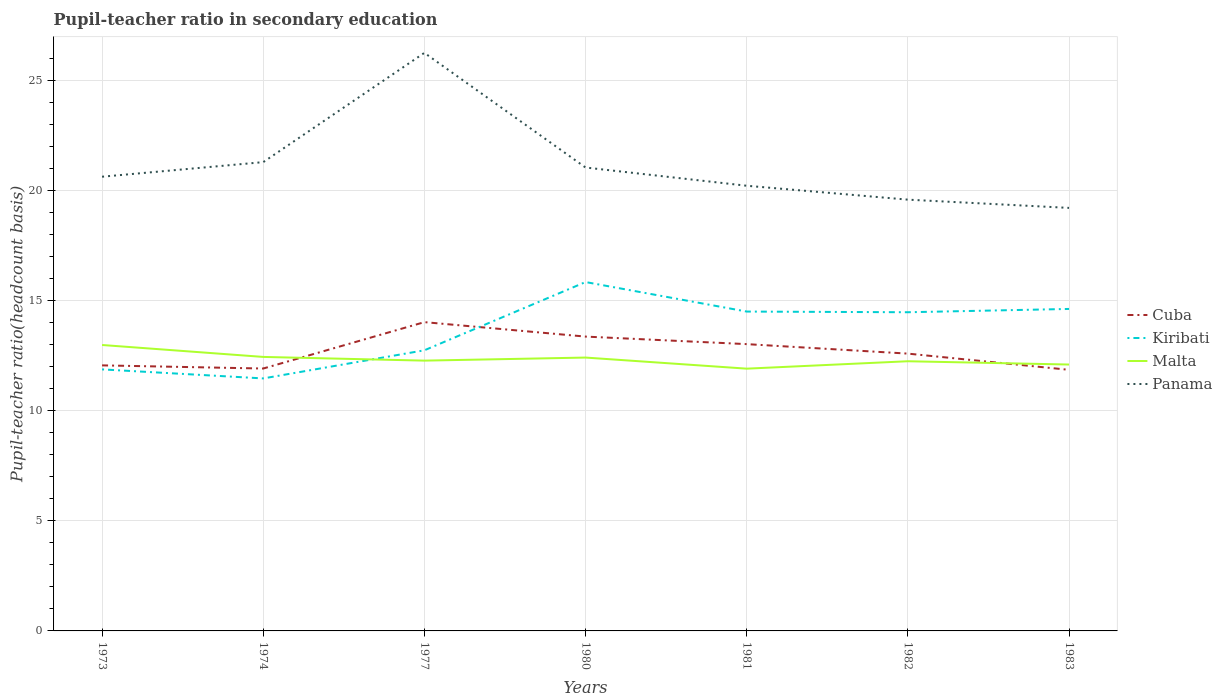How many different coloured lines are there?
Offer a very short reply. 4. Does the line corresponding to Kiribati intersect with the line corresponding to Cuba?
Ensure brevity in your answer.  Yes. Across all years, what is the maximum pupil-teacher ratio in secondary education in Panama?
Your answer should be compact. 19.21. What is the total pupil-teacher ratio in secondary education in Kiribati in the graph?
Your answer should be very brief. -4.38. What is the difference between the highest and the second highest pupil-teacher ratio in secondary education in Kiribati?
Provide a succinct answer. 4.38. How many lines are there?
Offer a very short reply. 4. How many years are there in the graph?
Keep it short and to the point. 7. Are the values on the major ticks of Y-axis written in scientific E-notation?
Provide a succinct answer. No. Does the graph contain any zero values?
Give a very brief answer. No. Does the graph contain grids?
Your response must be concise. Yes. How many legend labels are there?
Offer a very short reply. 4. How are the legend labels stacked?
Your answer should be very brief. Vertical. What is the title of the graph?
Your answer should be very brief. Pupil-teacher ratio in secondary education. What is the label or title of the Y-axis?
Provide a short and direct response. Pupil-teacher ratio(headcount basis). What is the Pupil-teacher ratio(headcount basis) in Cuba in 1973?
Your answer should be very brief. 12.06. What is the Pupil-teacher ratio(headcount basis) in Kiribati in 1973?
Your answer should be compact. 11.88. What is the Pupil-teacher ratio(headcount basis) of Malta in 1973?
Give a very brief answer. 12.99. What is the Pupil-teacher ratio(headcount basis) in Panama in 1973?
Provide a succinct answer. 20.63. What is the Pupil-teacher ratio(headcount basis) of Cuba in 1974?
Offer a very short reply. 11.92. What is the Pupil-teacher ratio(headcount basis) in Kiribati in 1974?
Offer a very short reply. 11.47. What is the Pupil-teacher ratio(headcount basis) in Malta in 1974?
Offer a very short reply. 12.44. What is the Pupil-teacher ratio(headcount basis) of Panama in 1974?
Your answer should be very brief. 21.29. What is the Pupil-teacher ratio(headcount basis) of Cuba in 1977?
Keep it short and to the point. 14.02. What is the Pupil-teacher ratio(headcount basis) of Kiribati in 1977?
Give a very brief answer. 12.75. What is the Pupil-teacher ratio(headcount basis) in Malta in 1977?
Your response must be concise. 12.28. What is the Pupil-teacher ratio(headcount basis) in Panama in 1977?
Offer a very short reply. 26.25. What is the Pupil-teacher ratio(headcount basis) in Cuba in 1980?
Your answer should be compact. 13.37. What is the Pupil-teacher ratio(headcount basis) in Kiribati in 1980?
Offer a very short reply. 15.84. What is the Pupil-teacher ratio(headcount basis) in Malta in 1980?
Give a very brief answer. 12.41. What is the Pupil-teacher ratio(headcount basis) in Panama in 1980?
Give a very brief answer. 21.05. What is the Pupil-teacher ratio(headcount basis) in Cuba in 1981?
Provide a short and direct response. 13.02. What is the Pupil-teacher ratio(headcount basis) of Kiribati in 1981?
Provide a short and direct response. 14.5. What is the Pupil-teacher ratio(headcount basis) in Malta in 1981?
Make the answer very short. 11.91. What is the Pupil-teacher ratio(headcount basis) of Panama in 1981?
Offer a very short reply. 20.22. What is the Pupil-teacher ratio(headcount basis) in Cuba in 1982?
Your answer should be very brief. 12.59. What is the Pupil-teacher ratio(headcount basis) of Kiribati in 1982?
Give a very brief answer. 14.47. What is the Pupil-teacher ratio(headcount basis) of Malta in 1982?
Keep it short and to the point. 12.25. What is the Pupil-teacher ratio(headcount basis) in Panama in 1982?
Make the answer very short. 19.59. What is the Pupil-teacher ratio(headcount basis) of Cuba in 1983?
Offer a very short reply. 11.86. What is the Pupil-teacher ratio(headcount basis) of Kiribati in 1983?
Ensure brevity in your answer.  14.62. What is the Pupil-teacher ratio(headcount basis) of Malta in 1983?
Make the answer very short. 12.1. What is the Pupil-teacher ratio(headcount basis) of Panama in 1983?
Provide a succinct answer. 19.21. Across all years, what is the maximum Pupil-teacher ratio(headcount basis) in Cuba?
Offer a very short reply. 14.02. Across all years, what is the maximum Pupil-teacher ratio(headcount basis) of Kiribati?
Offer a very short reply. 15.84. Across all years, what is the maximum Pupil-teacher ratio(headcount basis) of Malta?
Offer a terse response. 12.99. Across all years, what is the maximum Pupil-teacher ratio(headcount basis) in Panama?
Your answer should be compact. 26.25. Across all years, what is the minimum Pupil-teacher ratio(headcount basis) of Cuba?
Provide a short and direct response. 11.86. Across all years, what is the minimum Pupil-teacher ratio(headcount basis) of Kiribati?
Your answer should be compact. 11.47. Across all years, what is the minimum Pupil-teacher ratio(headcount basis) of Malta?
Ensure brevity in your answer.  11.91. Across all years, what is the minimum Pupil-teacher ratio(headcount basis) of Panama?
Make the answer very short. 19.21. What is the total Pupil-teacher ratio(headcount basis) of Cuba in the graph?
Ensure brevity in your answer.  88.85. What is the total Pupil-teacher ratio(headcount basis) of Kiribati in the graph?
Your response must be concise. 95.53. What is the total Pupil-teacher ratio(headcount basis) of Malta in the graph?
Ensure brevity in your answer.  86.38. What is the total Pupil-teacher ratio(headcount basis) in Panama in the graph?
Your answer should be very brief. 148.24. What is the difference between the Pupil-teacher ratio(headcount basis) in Cuba in 1973 and that in 1974?
Give a very brief answer. 0.14. What is the difference between the Pupil-teacher ratio(headcount basis) in Kiribati in 1973 and that in 1974?
Offer a very short reply. 0.41. What is the difference between the Pupil-teacher ratio(headcount basis) in Malta in 1973 and that in 1974?
Offer a very short reply. 0.54. What is the difference between the Pupil-teacher ratio(headcount basis) in Panama in 1973 and that in 1974?
Your response must be concise. -0.66. What is the difference between the Pupil-teacher ratio(headcount basis) in Cuba in 1973 and that in 1977?
Your response must be concise. -1.96. What is the difference between the Pupil-teacher ratio(headcount basis) of Kiribati in 1973 and that in 1977?
Make the answer very short. -0.87. What is the difference between the Pupil-teacher ratio(headcount basis) in Malta in 1973 and that in 1977?
Your answer should be compact. 0.71. What is the difference between the Pupil-teacher ratio(headcount basis) of Panama in 1973 and that in 1977?
Give a very brief answer. -5.63. What is the difference between the Pupil-teacher ratio(headcount basis) of Cuba in 1973 and that in 1980?
Make the answer very short. -1.31. What is the difference between the Pupil-teacher ratio(headcount basis) of Kiribati in 1973 and that in 1980?
Ensure brevity in your answer.  -3.97. What is the difference between the Pupil-teacher ratio(headcount basis) in Malta in 1973 and that in 1980?
Ensure brevity in your answer.  0.57. What is the difference between the Pupil-teacher ratio(headcount basis) in Panama in 1973 and that in 1980?
Provide a succinct answer. -0.42. What is the difference between the Pupil-teacher ratio(headcount basis) of Cuba in 1973 and that in 1981?
Offer a terse response. -0.96. What is the difference between the Pupil-teacher ratio(headcount basis) of Kiribati in 1973 and that in 1981?
Give a very brief answer. -2.63. What is the difference between the Pupil-teacher ratio(headcount basis) in Malta in 1973 and that in 1981?
Your response must be concise. 1.07. What is the difference between the Pupil-teacher ratio(headcount basis) in Panama in 1973 and that in 1981?
Ensure brevity in your answer.  0.41. What is the difference between the Pupil-teacher ratio(headcount basis) in Cuba in 1973 and that in 1982?
Ensure brevity in your answer.  -0.53. What is the difference between the Pupil-teacher ratio(headcount basis) of Kiribati in 1973 and that in 1982?
Your response must be concise. -2.6. What is the difference between the Pupil-teacher ratio(headcount basis) of Malta in 1973 and that in 1982?
Provide a succinct answer. 0.74. What is the difference between the Pupil-teacher ratio(headcount basis) in Panama in 1973 and that in 1982?
Offer a terse response. 1.04. What is the difference between the Pupil-teacher ratio(headcount basis) in Cuba in 1973 and that in 1983?
Your answer should be compact. 0.2. What is the difference between the Pupil-teacher ratio(headcount basis) in Kiribati in 1973 and that in 1983?
Give a very brief answer. -2.75. What is the difference between the Pupil-teacher ratio(headcount basis) in Malta in 1973 and that in 1983?
Keep it short and to the point. 0.89. What is the difference between the Pupil-teacher ratio(headcount basis) of Panama in 1973 and that in 1983?
Make the answer very short. 1.42. What is the difference between the Pupil-teacher ratio(headcount basis) in Cuba in 1974 and that in 1977?
Keep it short and to the point. -2.11. What is the difference between the Pupil-teacher ratio(headcount basis) of Kiribati in 1974 and that in 1977?
Your answer should be very brief. -1.28. What is the difference between the Pupil-teacher ratio(headcount basis) of Malta in 1974 and that in 1977?
Ensure brevity in your answer.  0.17. What is the difference between the Pupil-teacher ratio(headcount basis) in Panama in 1974 and that in 1977?
Make the answer very short. -4.96. What is the difference between the Pupil-teacher ratio(headcount basis) of Cuba in 1974 and that in 1980?
Your response must be concise. -1.45. What is the difference between the Pupil-teacher ratio(headcount basis) in Kiribati in 1974 and that in 1980?
Offer a very short reply. -4.38. What is the difference between the Pupil-teacher ratio(headcount basis) in Malta in 1974 and that in 1980?
Offer a very short reply. 0.03. What is the difference between the Pupil-teacher ratio(headcount basis) in Panama in 1974 and that in 1980?
Offer a terse response. 0.24. What is the difference between the Pupil-teacher ratio(headcount basis) of Cuba in 1974 and that in 1981?
Offer a very short reply. -1.11. What is the difference between the Pupil-teacher ratio(headcount basis) of Kiribati in 1974 and that in 1981?
Give a very brief answer. -3.04. What is the difference between the Pupil-teacher ratio(headcount basis) of Malta in 1974 and that in 1981?
Give a very brief answer. 0.53. What is the difference between the Pupil-teacher ratio(headcount basis) in Panama in 1974 and that in 1981?
Make the answer very short. 1.07. What is the difference between the Pupil-teacher ratio(headcount basis) in Cuba in 1974 and that in 1982?
Offer a very short reply. -0.68. What is the difference between the Pupil-teacher ratio(headcount basis) in Kiribati in 1974 and that in 1982?
Your answer should be very brief. -3.01. What is the difference between the Pupil-teacher ratio(headcount basis) in Malta in 1974 and that in 1982?
Keep it short and to the point. 0.2. What is the difference between the Pupil-teacher ratio(headcount basis) in Panama in 1974 and that in 1982?
Offer a terse response. 1.7. What is the difference between the Pupil-teacher ratio(headcount basis) of Cuba in 1974 and that in 1983?
Offer a terse response. 0.06. What is the difference between the Pupil-teacher ratio(headcount basis) of Kiribati in 1974 and that in 1983?
Give a very brief answer. -3.16. What is the difference between the Pupil-teacher ratio(headcount basis) of Malta in 1974 and that in 1983?
Offer a very short reply. 0.35. What is the difference between the Pupil-teacher ratio(headcount basis) of Panama in 1974 and that in 1983?
Keep it short and to the point. 2.08. What is the difference between the Pupil-teacher ratio(headcount basis) of Cuba in 1977 and that in 1980?
Keep it short and to the point. 0.66. What is the difference between the Pupil-teacher ratio(headcount basis) in Kiribati in 1977 and that in 1980?
Offer a very short reply. -3.1. What is the difference between the Pupil-teacher ratio(headcount basis) in Malta in 1977 and that in 1980?
Your answer should be very brief. -0.14. What is the difference between the Pupil-teacher ratio(headcount basis) in Panama in 1977 and that in 1980?
Keep it short and to the point. 5.21. What is the difference between the Pupil-teacher ratio(headcount basis) of Kiribati in 1977 and that in 1981?
Keep it short and to the point. -1.76. What is the difference between the Pupil-teacher ratio(headcount basis) in Malta in 1977 and that in 1981?
Keep it short and to the point. 0.37. What is the difference between the Pupil-teacher ratio(headcount basis) in Panama in 1977 and that in 1981?
Your answer should be compact. 6.04. What is the difference between the Pupil-teacher ratio(headcount basis) in Cuba in 1977 and that in 1982?
Your response must be concise. 1.43. What is the difference between the Pupil-teacher ratio(headcount basis) in Kiribati in 1977 and that in 1982?
Offer a very short reply. -1.73. What is the difference between the Pupil-teacher ratio(headcount basis) of Malta in 1977 and that in 1982?
Your response must be concise. 0.03. What is the difference between the Pupil-teacher ratio(headcount basis) in Panama in 1977 and that in 1982?
Your response must be concise. 6.67. What is the difference between the Pupil-teacher ratio(headcount basis) in Cuba in 1977 and that in 1983?
Make the answer very short. 2.17. What is the difference between the Pupil-teacher ratio(headcount basis) in Kiribati in 1977 and that in 1983?
Give a very brief answer. -1.88. What is the difference between the Pupil-teacher ratio(headcount basis) in Malta in 1977 and that in 1983?
Make the answer very short. 0.18. What is the difference between the Pupil-teacher ratio(headcount basis) in Panama in 1977 and that in 1983?
Your response must be concise. 7.04. What is the difference between the Pupil-teacher ratio(headcount basis) in Cuba in 1980 and that in 1981?
Provide a succinct answer. 0.34. What is the difference between the Pupil-teacher ratio(headcount basis) in Kiribati in 1980 and that in 1981?
Provide a short and direct response. 1.34. What is the difference between the Pupil-teacher ratio(headcount basis) in Malta in 1980 and that in 1981?
Make the answer very short. 0.5. What is the difference between the Pupil-teacher ratio(headcount basis) in Panama in 1980 and that in 1981?
Ensure brevity in your answer.  0.83. What is the difference between the Pupil-teacher ratio(headcount basis) in Cuba in 1980 and that in 1982?
Provide a short and direct response. 0.77. What is the difference between the Pupil-teacher ratio(headcount basis) of Kiribati in 1980 and that in 1982?
Give a very brief answer. 1.37. What is the difference between the Pupil-teacher ratio(headcount basis) of Malta in 1980 and that in 1982?
Your answer should be very brief. 0.17. What is the difference between the Pupil-teacher ratio(headcount basis) of Panama in 1980 and that in 1982?
Provide a succinct answer. 1.46. What is the difference between the Pupil-teacher ratio(headcount basis) in Cuba in 1980 and that in 1983?
Your response must be concise. 1.51. What is the difference between the Pupil-teacher ratio(headcount basis) in Kiribati in 1980 and that in 1983?
Keep it short and to the point. 1.22. What is the difference between the Pupil-teacher ratio(headcount basis) of Malta in 1980 and that in 1983?
Provide a short and direct response. 0.32. What is the difference between the Pupil-teacher ratio(headcount basis) of Panama in 1980 and that in 1983?
Provide a succinct answer. 1.83. What is the difference between the Pupil-teacher ratio(headcount basis) of Cuba in 1981 and that in 1982?
Your answer should be very brief. 0.43. What is the difference between the Pupil-teacher ratio(headcount basis) in Kiribati in 1981 and that in 1982?
Your response must be concise. 0.03. What is the difference between the Pupil-teacher ratio(headcount basis) of Malta in 1981 and that in 1982?
Your answer should be very brief. -0.34. What is the difference between the Pupil-teacher ratio(headcount basis) of Panama in 1981 and that in 1982?
Give a very brief answer. 0.63. What is the difference between the Pupil-teacher ratio(headcount basis) in Cuba in 1981 and that in 1983?
Provide a succinct answer. 1.17. What is the difference between the Pupil-teacher ratio(headcount basis) of Kiribati in 1981 and that in 1983?
Your response must be concise. -0.12. What is the difference between the Pupil-teacher ratio(headcount basis) in Malta in 1981 and that in 1983?
Your response must be concise. -0.19. What is the difference between the Pupil-teacher ratio(headcount basis) in Panama in 1981 and that in 1983?
Provide a short and direct response. 1.01. What is the difference between the Pupil-teacher ratio(headcount basis) of Cuba in 1982 and that in 1983?
Make the answer very short. 0.74. What is the difference between the Pupil-teacher ratio(headcount basis) of Kiribati in 1982 and that in 1983?
Offer a terse response. -0.15. What is the difference between the Pupil-teacher ratio(headcount basis) of Malta in 1982 and that in 1983?
Keep it short and to the point. 0.15. What is the difference between the Pupil-teacher ratio(headcount basis) in Panama in 1982 and that in 1983?
Your answer should be compact. 0.37. What is the difference between the Pupil-teacher ratio(headcount basis) of Cuba in 1973 and the Pupil-teacher ratio(headcount basis) of Kiribati in 1974?
Your response must be concise. 0.59. What is the difference between the Pupil-teacher ratio(headcount basis) of Cuba in 1973 and the Pupil-teacher ratio(headcount basis) of Malta in 1974?
Provide a short and direct response. -0.38. What is the difference between the Pupil-teacher ratio(headcount basis) in Cuba in 1973 and the Pupil-teacher ratio(headcount basis) in Panama in 1974?
Your answer should be compact. -9.23. What is the difference between the Pupil-teacher ratio(headcount basis) of Kiribati in 1973 and the Pupil-teacher ratio(headcount basis) of Malta in 1974?
Your response must be concise. -0.57. What is the difference between the Pupil-teacher ratio(headcount basis) of Kiribati in 1973 and the Pupil-teacher ratio(headcount basis) of Panama in 1974?
Your answer should be compact. -9.41. What is the difference between the Pupil-teacher ratio(headcount basis) of Malta in 1973 and the Pupil-teacher ratio(headcount basis) of Panama in 1974?
Your answer should be compact. -8.3. What is the difference between the Pupil-teacher ratio(headcount basis) of Cuba in 1973 and the Pupil-teacher ratio(headcount basis) of Kiribati in 1977?
Keep it short and to the point. -0.68. What is the difference between the Pupil-teacher ratio(headcount basis) of Cuba in 1973 and the Pupil-teacher ratio(headcount basis) of Malta in 1977?
Offer a terse response. -0.22. What is the difference between the Pupil-teacher ratio(headcount basis) in Cuba in 1973 and the Pupil-teacher ratio(headcount basis) in Panama in 1977?
Offer a terse response. -14.19. What is the difference between the Pupil-teacher ratio(headcount basis) of Kiribati in 1973 and the Pupil-teacher ratio(headcount basis) of Malta in 1977?
Give a very brief answer. -0.4. What is the difference between the Pupil-teacher ratio(headcount basis) in Kiribati in 1973 and the Pupil-teacher ratio(headcount basis) in Panama in 1977?
Give a very brief answer. -14.38. What is the difference between the Pupil-teacher ratio(headcount basis) of Malta in 1973 and the Pupil-teacher ratio(headcount basis) of Panama in 1977?
Your answer should be very brief. -13.27. What is the difference between the Pupil-teacher ratio(headcount basis) in Cuba in 1973 and the Pupil-teacher ratio(headcount basis) in Kiribati in 1980?
Your answer should be compact. -3.78. What is the difference between the Pupil-teacher ratio(headcount basis) in Cuba in 1973 and the Pupil-teacher ratio(headcount basis) in Malta in 1980?
Your response must be concise. -0.35. What is the difference between the Pupil-teacher ratio(headcount basis) of Cuba in 1973 and the Pupil-teacher ratio(headcount basis) of Panama in 1980?
Offer a very short reply. -8.99. What is the difference between the Pupil-teacher ratio(headcount basis) of Kiribati in 1973 and the Pupil-teacher ratio(headcount basis) of Malta in 1980?
Your answer should be compact. -0.54. What is the difference between the Pupil-teacher ratio(headcount basis) in Kiribati in 1973 and the Pupil-teacher ratio(headcount basis) in Panama in 1980?
Ensure brevity in your answer.  -9.17. What is the difference between the Pupil-teacher ratio(headcount basis) in Malta in 1973 and the Pupil-teacher ratio(headcount basis) in Panama in 1980?
Make the answer very short. -8.06. What is the difference between the Pupil-teacher ratio(headcount basis) in Cuba in 1973 and the Pupil-teacher ratio(headcount basis) in Kiribati in 1981?
Offer a very short reply. -2.44. What is the difference between the Pupil-teacher ratio(headcount basis) in Cuba in 1973 and the Pupil-teacher ratio(headcount basis) in Malta in 1981?
Your answer should be very brief. 0.15. What is the difference between the Pupil-teacher ratio(headcount basis) in Cuba in 1973 and the Pupil-teacher ratio(headcount basis) in Panama in 1981?
Provide a succinct answer. -8.16. What is the difference between the Pupil-teacher ratio(headcount basis) in Kiribati in 1973 and the Pupil-teacher ratio(headcount basis) in Malta in 1981?
Ensure brevity in your answer.  -0.03. What is the difference between the Pupil-teacher ratio(headcount basis) in Kiribati in 1973 and the Pupil-teacher ratio(headcount basis) in Panama in 1981?
Your answer should be very brief. -8.34. What is the difference between the Pupil-teacher ratio(headcount basis) in Malta in 1973 and the Pupil-teacher ratio(headcount basis) in Panama in 1981?
Your answer should be very brief. -7.23. What is the difference between the Pupil-teacher ratio(headcount basis) in Cuba in 1973 and the Pupil-teacher ratio(headcount basis) in Kiribati in 1982?
Keep it short and to the point. -2.41. What is the difference between the Pupil-teacher ratio(headcount basis) in Cuba in 1973 and the Pupil-teacher ratio(headcount basis) in Malta in 1982?
Keep it short and to the point. -0.19. What is the difference between the Pupil-teacher ratio(headcount basis) in Cuba in 1973 and the Pupil-teacher ratio(headcount basis) in Panama in 1982?
Provide a succinct answer. -7.53. What is the difference between the Pupil-teacher ratio(headcount basis) in Kiribati in 1973 and the Pupil-teacher ratio(headcount basis) in Malta in 1982?
Provide a succinct answer. -0.37. What is the difference between the Pupil-teacher ratio(headcount basis) in Kiribati in 1973 and the Pupil-teacher ratio(headcount basis) in Panama in 1982?
Offer a very short reply. -7.71. What is the difference between the Pupil-teacher ratio(headcount basis) of Malta in 1973 and the Pupil-teacher ratio(headcount basis) of Panama in 1982?
Provide a short and direct response. -6.6. What is the difference between the Pupil-teacher ratio(headcount basis) in Cuba in 1973 and the Pupil-teacher ratio(headcount basis) in Kiribati in 1983?
Keep it short and to the point. -2.56. What is the difference between the Pupil-teacher ratio(headcount basis) in Cuba in 1973 and the Pupil-teacher ratio(headcount basis) in Malta in 1983?
Your answer should be very brief. -0.04. What is the difference between the Pupil-teacher ratio(headcount basis) in Cuba in 1973 and the Pupil-teacher ratio(headcount basis) in Panama in 1983?
Offer a terse response. -7.15. What is the difference between the Pupil-teacher ratio(headcount basis) of Kiribati in 1973 and the Pupil-teacher ratio(headcount basis) of Malta in 1983?
Provide a succinct answer. -0.22. What is the difference between the Pupil-teacher ratio(headcount basis) in Kiribati in 1973 and the Pupil-teacher ratio(headcount basis) in Panama in 1983?
Ensure brevity in your answer.  -7.33. What is the difference between the Pupil-teacher ratio(headcount basis) in Malta in 1973 and the Pupil-teacher ratio(headcount basis) in Panama in 1983?
Make the answer very short. -6.23. What is the difference between the Pupil-teacher ratio(headcount basis) of Cuba in 1974 and the Pupil-teacher ratio(headcount basis) of Kiribati in 1977?
Keep it short and to the point. -0.83. What is the difference between the Pupil-teacher ratio(headcount basis) of Cuba in 1974 and the Pupil-teacher ratio(headcount basis) of Malta in 1977?
Offer a terse response. -0.36. What is the difference between the Pupil-teacher ratio(headcount basis) of Cuba in 1974 and the Pupil-teacher ratio(headcount basis) of Panama in 1977?
Your answer should be compact. -14.34. What is the difference between the Pupil-teacher ratio(headcount basis) of Kiribati in 1974 and the Pupil-teacher ratio(headcount basis) of Malta in 1977?
Provide a succinct answer. -0.81. What is the difference between the Pupil-teacher ratio(headcount basis) in Kiribati in 1974 and the Pupil-teacher ratio(headcount basis) in Panama in 1977?
Make the answer very short. -14.79. What is the difference between the Pupil-teacher ratio(headcount basis) in Malta in 1974 and the Pupil-teacher ratio(headcount basis) in Panama in 1977?
Keep it short and to the point. -13.81. What is the difference between the Pupil-teacher ratio(headcount basis) of Cuba in 1974 and the Pupil-teacher ratio(headcount basis) of Kiribati in 1980?
Give a very brief answer. -3.93. What is the difference between the Pupil-teacher ratio(headcount basis) of Cuba in 1974 and the Pupil-teacher ratio(headcount basis) of Malta in 1980?
Offer a very short reply. -0.5. What is the difference between the Pupil-teacher ratio(headcount basis) of Cuba in 1974 and the Pupil-teacher ratio(headcount basis) of Panama in 1980?
Your answer should be very brief. -9.13. What is the difference between the Pupil-teacher ratio(headcount basis) of Kiribati in 1974 and the Pupil-teacher ratio(headcount basis) of Malta in 1980?
Make the answer very short. -0.95. What is the difference between the Pupil-teacher ratio(headcount basis) of Kiribati in 1974 and the Pupil-teacher ratio(headcount basis) of Panama in 1980?
Your response must be concise. -9.58. What is the difference between the Pupil-teacher ratio(headcount basis) in Malta in 1974 and the Pupil-teacher ratio(headcount basis) in Panama in 1980?
Give a very brief answer. -8.6. What is the difference between the Pupil-teacher ratio(headcount basis) of Cuba in 1974 and the Pupil-teacher ratio(headcount basis) of Kiribati in 1981?
Offer a very short reply. -2.59. What is the difference between the Pupil-teacher ratio(headcount basis) of Cuba in 1974 and the Pupil-teacher ratio(headcount basis) of Malta in 1981?
Give a very brief answer. 0.01. What is the difference between the Pupil-teacher ratio(headcount basis) of Cuba in 1974 and the Pupil-teacher ratio(headcount basis) of Panama in 1981?
Offer a very short reply. -8.3. What is the difference between the Pupil-teacher ratio(headcount basis) in Kiribati in 1974 and the Pupil-teacher ratio(headcount basis) in Malta in 1981?
Provide a succinct answer. -0.44. What is the difference between the Pupil-teacher ratio(headcount basis) in Kiribati in 1974 and the Pupil-teacher ratio(headcount basis) in Panama in 1981?
Provide a short and direct response. -8.75. What is the difference between the Pupil-teacher ratio(headcount basis) of Malta in 1974 and the Pupil-teacher ratio(headcount basis) of Panama in 1981?
Provide a short and direct response. -7.77. What is the difference between the Pupil-teacher ratio(headcount basis) in Cuba in 1974 and the Pupil-teacher ratio(headcount basis) in Kiribati in 1982?
Your answer should be compact. -2.56. What is the difference between the Pupil-teacher ratio(headcount basis) in Cuba in 1974 and the Pupil-teacher ratio(headcount basis) in Malta in 1982?
Offer a terse response. -0.33. What is the difference between the Pupil-teacher ratio(headcount basis) of Cuba in 1974 and the Pupil-teacher ratio(headcount basis) of Panama in 1982?
Your answer should be compact. -7.67. What is the difference between the Pupil-teacher ratio(headcount basis) in Kiribati in 1974 and the Pupil-teacher ratio(headcount basis) in Malta in 1982?
Ensure brevity in your answer.  -0.78. What is the difference between the Pupil-teacher ratio(headcount basis) in Kiribati in 1974 and the Pupil-teacher ratio(headcount basis) in Panama in 1982?
Your answer should be compact. -8.12. What is the difference between the Pupil-teacher ratio(headcount basis) of Malta in 1974 and the Pupil-teacher ratio(headcount basis) of Panama in 1982?
Ensure brevity in your answer.  -7.14. What is the difference between the Pupil-teacher ratio(headcount basis) of Cuba in 1974 and the Pupil-teacher ratio(headcount basis) of Kiribati in 1983?
Provide a succinct answer. -2.71. What is the difference between the Pupil-teacher ratio(headcount basis) in Cuba in 1974 and the Pupil-teacher ratio(headcount basis) in Malta in 1983?
Provide a succinct answer. -0.18. What is the difference between the Pupil-teacher ratio(headcount basis) of Cuba in 1974 and the Pupil-teacher ratio(headcount basis) of Panama in 1983?
Provide a short and direct response. -7.29. What is the difference between the Pupil-teacher ratio(headcount basis) of Kiribati in 1974 and the Pupil-teacher ratio(headcount basis) of Malta in 1983?
Keep it short and to the point. -0.63. What is the difference between the Pupil-teacher ratio(headcount basis) in Kiribati in 1974 and the Pupil-teacher ratio(headcount basis) in Panama in 1983?
Offer a terse response. -7.74. What is the difference between the Pupil-teacher ratio(headcount basis) of Malta in 1974 and the Pupil-teacher ratio(headcount basis) of Panama in 1983?
Make the answer very short. -6.77. What is the difference between the Pupil-teacher ratio(headcount basis) of Cuba in 1977 and the Pupil-teacher ratio(headcount basis) of Kiribati in 1980?
Keep it short and to the point. -1.82. What is the difference between the Pupil-teacher ratio(headcount basis) of Cuba in 1977 and the Pupil-teacher ratio(headcount basis) of Malta in 1980?
Your response must be concise. 1.61. What is the difference between the Pupil-teacher ratio(headcount basis) in Cuba in 1977 and the Pupil-teacher ratio(headcount basis) in Panama in 1980?
Your answer should be very brief. -7.02. What is the difference between the Pupil-teacher ratio(headcount basis) of Kiribati in 1977 and the Pupil-teacher ratio(headcount basis) of Malta in 1980?
Ensure brevity in your answer.  0.33. What is the difference between the Pupil-teacher ratio(headcount basis) in Kiribati in 1977 and the Pupil-teacher ratio(headcount basis) in Panama in 1980?
Ensure brevity in your answer.  -8.3. What is the difference between the Pupil-teacher ratio(headcount basis) of Malta in 1977 and the Pupil-teacher ratio(headcount basis) of Panama in 1980?
Your answer should be very brief. -8.77. What is the difference between the Pupil-teacher ratio(headcount basis) in Cuba in 1977 and the Pupil-teacher ratio(headcount basis) in Kiribati in 1981?
Give a very brief answer. -0.48. What is the difference between the Pupil-teacher ratio(headcount basis) of Cuba in 1977 and the Pupil-teacher ratio(headcount basis) of Malta in 1981?
Your answer should be compact. 2.11. What is the difference between the Pupil-teacher ratio(headcount basis) of Cuba in 1977 and the Pupil-teacher ratio(headcount basis) of Panama in 1981?
Give a very brief answer. -6.19. What is the difference between the Pupil-teacher ratio(headcount basis) in Kiribati in 1977 and the Pupil-teacher ratio(headcount basis) in Malta in 1981?
Your response must be concise. 0.83. What is the difference between the Pupil-teacher ratio(headcount basis) in Kiribati in 1977 and the Pupil-teacher ratio(headcount basis) in Panama in 1981?
Ensure brevity in your answer.  -7.47. What is the difference between the Pupil-teacher ratio(headcount basis) of Malta in 1977 and the Pupil-teacher ratio(headcount basis) of Panama in 1981?
Ensure brevity in your answer.  -7.94. What is the difference between the Pupil-teacher ratio(headcount basis) of Cuba in 1977 and the Pupil-teacher ratio(headcount basis) of Kiribati in 1982?
Ensure brevity in your answer.  -0.45. What is the difference between the Pupil-teacher ratio(headcount basis) of Cuba in 1977 and the Pupil-teacher ratio(headcount basis) of Malta in 1982?
Ensure brevity in your answer.  1.78. What is the difference between the Pupil-teacher ratio(headcount basis) of Cuba in 1977 and the Pupil-teacher ratio(headcount basis) of Panama in 1982?
Make the answer very short. -5.56. What is the difference between the Pupil-teacher ratio(headcount basis) in Kiribati in 1977 and the Pupil-teacher ratio(headcount basis) in Malta in 1982?
Offer a terse response. 0.5. What is the difference between the Pupil-teacher ratio(headcount basis) in Kiribati in 1977 and the Pupil-teacher ratio(headcount basis) in Panama in 1982?
Offer a very short reply. -6.84. What is the difference between the Pupil-teacher ratio(headcount basis) in Malta in 1977 and the Pupil-teacher ratio(headcount basis) in Panama in 1982?
Make the answer very short. -7.31. What is the difference between the Pupil-teacher ratio(headcount basis) of Cuba in 1977 and the Pupil-teacher ratio(headcount basis) of Kiribati in 1983?
Give a very brief answer. -0.6. What is the difference between the Pupil-teacher ratio(headcount basis) of Cuba in 1977 and the Pupil-teacher ratio(headcount basis) of Malta in 1983?
Provide a short and direct response. 1.93. What is the difference between the Pupil-teacher ratio(headcount basis) in Cuba in 1977 and the Pupil-teacher ratio(headcount basis) in Panama in 1983?
Keep it short and to the point. -5.19. What is the difference between the Pupil-teacher ratio(headcount basis) of Kiribati in 1977 and the Pupil-teacher ratio(headcount basis) of Malta in 1983?
Provide a short and direct response. 0.65. What is the difference between the Pupil-teacher ratio(headcount basis) in Kiribati in 1977 and the Pupil-teacher ratio(headcount basis) in Panama in 1983?
Your answer should be compact. -6.47. What is the difference between the Pupil-teacher ratio(headcount basis) of Malta in 1977 and the Pupil-teacher ratio(headcount basis) of Panama in 1983?
Make the answer very short. -6.94. What is the difference between the Pupil-teacher ratio(headcount basis) of Cuba in 1980 and the Pupil-teacher ratio(headcount basis) of Kiribati in 1981?
Offer a terse response. -1.14. What is the difference between the Pupil-teacher ratio(headcount basis) in Cuba in 1980 and the Pupil-teacher ratio(headcount basis) in Malta in 1981?
Your response must be concise. 1.46. What is the difference between the Pupil-teacher ratio(headcount basis) of Cuba in 1980 and the Pupil-teacher ratio(headcount basis) of Panama in 1981?
Provide a succinct answer. -6.85. What is the difference between the Pupil-teacher ratio(headcount basis) in Kiribati in 1980 and the Pupil-teacher ratio(headcount basis) in Malta in 1981?
Your response must be concise. 3.93. What is the difference between the Pupil-teacher ratio(headcount basis) of Kiribati in 1980 and the Pupil-teacher ratio(headcount basis) of Panama in 1981?
Keep it short and to the point. -4.37. What is the difference between the Pupil-teacher ratio(headcount basis) in Malta in 1980 and the Pupil-teacher ratio(headcount basis) in Panama in 1981?
Make the answer very short. -7.8. What is the difference between the Pupil-teacher ratio(headcount basis) in Cuba in 1980 and the Pupil-teacher ratio(headcount basis) in Kiribati in 1982?
Keep it short and to the point. -1.11. What is the difference between the Pupil-teacher ratio(headcount basis) of Cuba in 1980 and the Pupil-teacher ratio(headcount basis) of Malta in 1982?
Offer a very short reply. 1.12. What is the difference between the Pupil-teacher ratio(headcount basis) in Cuba in 1980 and the Pupil-teacher ratio(headcount basis) in Panama in 1982?
Offer a terse response. -6.22. What is the difference between the Pupil-teacher ratio(headcount basis) of Kiribati in 1980 and the Pupil-teacher ratio(headcount basis) of Malta in 1982?
Ensure brevity in your answer.  3.6. What is the difference between the Pupil-teacher ratio(headcount basis) in Kiribati in 1980 and the Pupil-teacher ratio(headcount basis) in Panama in 1982?
Your response must be concise. -3.74. What is the difference between the Pupil-teacher ratio(headcount basis) in Malta in 1980 and the Pupil-teacher ratio(headcount basis) in Panama in 1982?
Your response must be concise. -7.17. What is the difference between the Pupil-teacher ratio(headcount basis) in Cuba in 1980 and the Pupil-teacher ratio(headcount basis) in Kiribati in 1983?
Provide a succinct answer. -1.26. What is the difference between the Pupil-teacher ratio(headcount basis) in Cuba in 1980 and the Pupil-teacher ratio(headcount basis) in Malta in 1983?
Keep it short and to the point. 1.27. What is the difference between the Pupil-teacher ratio(headcount basis) of Cuba in 1980 and the Pupil-teacher ratio(headcount basis) of Panama in 1983?
Your response must be concise. -5.84. What is the difference between the Pupil-teacher ratio(headcount basis) of Kiribati in 1980 and the Pupil-teacher ratio(headcount basis) of Malta in 1983?
Offer a terse response. 3.75. What is the difference between the Pupil-teacher ratio(headcount basis) of Kiribati in 1980 and the Pupil-teacher ratio(headcount basis) of Panama in 1983?
Your answer should be very brief. -3.37. What is the difference between the Pupil-teacher ratio(headcount basis) of Malta in 1980 and the Pupil-teacher ratio(headcount basis) of Panama in 1983?
Offer a very short reply. -6.8. What is the difference between the Pupil-teacher ratio(headcount basis) in Cuba in 1981 and the Pupil-teacher ratio(headcount basis) in Kiribati in 1982?
Provide a succinct answer. -1.45. What is the difference between the Pupil-teacher ratio(headcount basis) of Cuba in 1981 and the Pupil-teacher ratio(headcount basis) of Malta in 1982?
Your response must be concise. 0.78. What is the difference between the Pupil-teacher ratio(headcount basis) in Cuba in 1981 and the Pupil-teacher ratio(headcount basis) in Panama in 1982?
Your response must be concise. -6.56. What is the difference between the Pupil-teacher ratio(headcount basis) of Kiribati in 1981 and the Pupil-teacher ratio(headcount basis) of Malta in 1982?
Ensure brevity in your answer.  2.26. What is the difference between the Pupil-teacher ratio(headcount basis) in Kiribati in 1981 and the Pupil-teacher ratio(headcount basis) in Panama in 1982?
Give a very brief answer. -5.08. What is the difference between the Pupil-teacher ratio(headcount basis) of Malta in 1981 and the Pupil-teacher ratio(headcount basis) of Panama in 1982?
Your answer should be very brief. -7.68. What is the difference between the Pupil-teacher ratio(headcount basis) in Cuba in 1981 and the Pupil-teacher ratio(headcount basis) in Kiribati in 1983?
Offer a very short reply. -1.6. What is the difference between the Pupil-teacher ratio(headcount basis) of Cuba in 1981 and the Pupil-teacher ratio(headcount basis) of Malta in 1983?
Offer a terse response. 0.93. What is the difference between the Pupil-teacher ratio(headcount basis) of Cuba in 1981 and the Pupil-teacher ratio(headcount basis) of Panama in 1983?
Your answer should be compact. -6.19. What is the difference between the Pupil-teacher ratio(headcount basis) of Kiribati in 1981 and the Pupil-teacher ratio(headcount basis) of Malta in 1983?
Your answer should be very brief. 2.41. What is the difference between the Pupil-teacher ratio(headcount basis) in Kiribati in 1981 and the Pupil-teacher ratio(headcount basis) in Panama in 1983?
Your response must be concise. -4.71. What is the difference between the Pupil-teacher ratio(headcount basis) of Malta in 1981 and the Pupil-teacher ratio(headcount basis) of Panama in 1983?
Your answer should be very brief. -7.3. What is the difference between the Pupil-teacher ratio(headcount basis) in Cuba in 1982 and the Pupil-teacher ratio(headcount basis) in Kiribati in 1983?
Your answer should be compact. -2.03. What is the difference between the Pupil-teacher ratio(headcount basis) of Cuba in 1982 and the Pupil-teacher ratio(headcount basis) of Malta in 1983?
Offer a terse response. 0.5. What is the difference between the Pupil-teacher ratio(headcount basis) in Cuba in 1982 and the Pupil-teacher ratio(headcount basis) in Panama in 1983?
Give a very brief answer. -6.62. What is the difference between the Pupil-teacher ratio(headcount basis) of Kiribati in 1982 and the Pupil-teacher ratio(headcount basis) of Malta in 1983?
Offer a very short reply. 2.38. What is the difference between the Pupil-teacher ratio(headcount basis) of Kiribati in 1982 and the Pupil-teacher ratio(headcount basis) of Panama in 1983?
Your response must be concise. -4.74. What is the difference between the Pupil-teacher ratio(headcount basis) in Malta in 1982 and the Pupil-teacher ratio(headcount basis) in Panama in 1983?
Your response must be concise. -6.96. What is the average Pupil-teacher ratio(headcount basis) of Cuba per year?
Provide a succinct answer. 12.69. What is the average Pupil-teacher ratio(headcount basis) in Kiribati per year?
Provide a short and direct response. 13.65. What is the average Pupil-teacher ratio(headcount basis) of Malta per year?
Your answer should be very brief. 12.34. What is the average Pupil-teacher ratio(headcount basis) in Panama per year?
Offer a terse response. 21.18. In the year 1973, what is the difference between the Pupil-teacher ratio(headcount basis) in Cuba and Pupil-teacher ratio(headcount basis) in Kiribati?
Give a very brief answer. 0.18. In the year 1973, what is the difference between the Pupil-teacher ratio(headcount basis) in Cuba and Pupil-teacher ratio(headcount basis) in Malta?
Your answer should be very brief. -0.93. In the year 1973, what is the difference between the Pupil-teacher ratio(headcount basis) of Cuba and Pupil-teacher ratio(headcount basis) of Panama?
Your answer should be very brief. -8.57. In the year 1973, what is the difference between the Pupil-teacher ratio(headcount basis) in Kiribati and Pupil-teacher ratio(headcount basis) in Malta?
Your answer should be very brief. -1.11. In the year 1973, what is the difference between the Pupil-teacher ratio(headcount basis) of Kiribati and Pupil-teacher ratio(headcount basis) of Panama?
Keep it short and to the point. -8.75. In the year 1973, what is the difference between the Pupil-teacher ratio(headcount basis) of Malta and Pupil-teacher ratio(headcount basis) of Panama?
Keep it short and to the point. -7.64. In the year 1974, what is the difference between the Pupil-teacher ratio(headcount basis) of Cuba and Pupil-teacher ratio(headcount basis) of Kiribati?
Give a very brief answer. 0.45. In the year 1974, what is the difference between the Pupil-teacher ratio(headcount basis) in Cuba and Pupil-teacher ratio(headcount basis) in Malta?
Your response must be concise. -0.53. In the year 1974, what is the difference between the Pupil-teacher ratio(headcount basis) of Cuba and Pupil-teacher ratio(headcount basis) of Panama?
Offer a very short reply. -9.37. In the year 1974, what is the difference between the Pupil-teacher ratio(headcount basis) in Kiribati and Pupil-teacher ratio(headcount basis) in Malta?
Give a very brief answer. -0.98. In the year 1974, what is the difference between the Pupil-teacher ratio(headcount basis) in Kiribati and Pupil-teacher ratio(headcount basis) in Panama?
Ensure brevity in your answer.  -9.82. In the year 1974, what is the difference between the Pupil-teacher ratio(headcount basis) of Malta and Pupil-teacher ratio(headcount basis) of Panama?
Provide a short and direct response. -8.85. In the year 1977, what is the difference between the Pupil-teacher ratio(headcount basis) of Cuba and Pupil-teacher ratio(headcount basis) of Kiribati?
Your answer should be very brief. 1.28. In the year 1977, what is the difference between the Pupil-teacher ratio(headcount basis) of Cuba and Pupil-teacher ratio(headcount basis) of Malta?
Your response must be concise. 1.75. In the year 1977, what is the difference between the Pupil-teacher ratio(headcount basis) of Cuba and Pupil-teacher ratio(headcount basis) of Panama?
Keep it short and to the point. -12.23. In the year 1977, what is the difference between the Pupil-teacher ratio(headcount basis) in Kiribati and Pupil-teacher ratio(headcount basis) in Malta?
Make the answer very short. 0.47. In the year 1977, what is the difference between the Pupil-teacher ratio(headcount basis) of Kiribati and Pupil-teacher ratio(headcount basis) of Panama?
Offer a very short reply. -13.51. In the year 1977, what is the difference between the Pupil-teacher ratio(headcount basis) in Malta and Pupil-teacher ratio(headcount basis) in Panama?
Your answer should be compact. -13.98. In the year 1980, what is the difference between the Pupil-teacher ratio(headcount basis) in Cuba and Pupil-teacher ratio(headcount basis) in Kiribati?
Offer a very short reply. -2.48. In the year 1980, what is the difference between the Pupil-teacher ratio(headcount basis) of Cuba and Pupil-teacher ratio(headcount basis) of Malta?
Your answer should be very brief. 0.95. In the year 1980, what is the difference between the Pupil-teacher ratio(headcount basis) in Cuba and Pupil-teacher ratio(headcount basis) in Panama?
Give a very brief answer. -7.68. In the year 1980, what is the difference between the Pupil-teacher ratio(headcount basis) of Kiribati and Pupil-teacher ratio(headcount basis) of Malta?
Make the answer very short. 3.43. In the year 1980, what is the difference between the Pupil-teacher ratio(headcount basis) of Kiribati and Pupil-teacher ratio(headcount basis) of Panama?
Your response must be concise. -5.2. In the year 1980, what is the difference between the Pupil-teacher ratio(headcount basis) in Malta and Pupil-teacher ratio(headcount basis) in Panama?
Your response must be concise. -8.63. In the year 1981, what is the difference between the Pupil-teacher ratio(headcount basis) in Cuba and Pupil-teacher ratio(headcount basis) in Kiribati?
Provide a succinct answer. -1.48. In the year 1981, what is the difference between the Pupil-teacher ratio(headcount basis) of Cuba and Pupil-teacher ratio(headcount basis) of Malta?
Provide a succinct answer. 1.11. In the year 1981, what is the difference between the Pupil-teacher ratio(headcount basis) in Cuba and Pupil-teacher ratio(headcount basis) in Panama?
Provide a short and direct response. -7.19. In the year 1981, what is the difference between the Pupil-teacher ratio(headcount basis) in Kiribati and Pupil-teacher ratio(headcount basis) in Malta?
Keep it short and to the point. 2.59. In the year 1981, what is the difference between the Pupil-teacher ratio(headcount basis) in Kiribati and Pupil-teacher ratio(headcount basis) in Panama?
Offer a terse response. -5.71. In the year 1981, what is the difference between the Pupil-teacher ratio(headcount basis) of Malta and Pupil-teacher ratio(headcount basis) of Panama?
Your answer should be compact. -8.31. In the year 1982, what is the difference between the Pupil-teacher ratio(headcount basis) in Cuba and Pupil-teacher ratio(headcount basis) in Kiribati?
Provide a succinct answer. -1.88. In the year 1982, what is the difference between the Pupil-teacher ratio(headcount basis) in Cuba and Pupil-teacher ratio(headcount basis) in Malta?
Make the answer very short. 0.35. In the year 1982, what is the difference between the Pupil-teacher ratio(headcount basis) of Cuba and Pupil-teacher ratio(headcount basis) of Panama?
Provide a short and direct response. -6.99. In the year 1982, what is the difference between the Pupil-teacher ratio(headcount basis) in Kiribati and Pupil-teacher ratio(headcount basis) in Malta?
Ensure brevity in your answer.  2.23. In the year 1982, what is the difference between the Pupil-teacher ratio(headcount basis) in Kiribati and Pupil-teacher ratio(headcount basis) in Panama?
Give a very brief answer. -5.11. In the year 1982, what is the difference between the Pupil-teacher ratio(headcount basis) of Malta and Pupil-teacher ratio(headcount basis) of Panama?
Your answer should be compact. -7.34. In the year 1983, what is the difference between the Pupil-teacher ratio(headcount basis) in Cuba and Pupil-teacher ratio(headcount basis) in Kiribati?
Give a very brief answer. -2.77. In the year 1983, what is the difference between the Pupil-teacher ratio(headcount basis) in Cuba and Pupil-teacher ratio(headcount basis) in Malta?
Make the answer very short. -0.24. In the year 1983, what is the difference between the Pupil-teacher ratio(headcount basis) of Cuba and Pupil-teacher ratio(headcount basis) of Panama?
Provide a succinct answer. -7.35. In the year 1983, what is the difference between the Pupil-teacher ratio(headcount basis) of Kiribati and Pupil-teacher ratio(headcount basis) of Malta?
Ensure brevity in your answer.  2.52. In the year 1983, what is the difference between the Pupil-teacher ratio(headcount basis) in Kiribati and Pupil-teacher ratio(headcount basis) in Panama?
Offer a terse response. -4.59. In the year 1983, what is the difference between the Pupil-teacher ratio(headcount basis) of Malta and Pupil-teacher ratio(headcount basis) of Panama?
Provide a succinct answer. -7.11. What is the ratio of the Pupil-teacher ratio(headcount basis) in Kiribati in 1973 to that in 1974?
Provide a succinct answer. 1.04. What is the ratio of the Pupil-teacher ratio(headcount basis) in Malta in 1973 to that in 1974?
Give a very brief answer. 1.04. What is the ratio of the Pupil-teacher ratio(headcount basis) in Panama in 1973 to that in 1974?
Offer a very short reply. 0.97. What is the ratio of the Pupil-teacher ratio(headcount basis) of Cuba in 1973 to that in 1977?
Keep it short and to the point. 0.86. What is the ratio of the Pupil-teacher ratio(headcount basis) of Kiribati in 1973 to that in 1977?
Your answer should be very brief. 0.93. What is the ratio of the Pupil-teacher ratio(headcount basis) of Malta in 1973 to that in 1977?
Ensure brevity in your answer.  1.06. What is the ratio of the Pupil-teacher ratio(headcount basis) in Panama in 1973 to that in 1977?
Your answer should be very brief. 0.79. What is the ratio of the Pupil-teacher ratio(headcount basis) of Cuba in 1973 to that in 1980?
Give a very brief answer. 0.9. What is the ratio of the Pupil-teacher ratio(headcount basis) in Kiribati in 1973 to that in 1980?
Ensure brevity in your answer.  0.75. What is the ratio of the Pupil-teacher ratio(headcount basis) in Malta in 1973 to that in 1980?
Offer a very short reply. 1.05. What is the ratio of the Pupil-teacher ratio(headcount basis) in Panama in 1973 to that in 1980?
Provide a short and direct response. 0.98. What is the ratio of the Pupil-teacher ratio(headcount basis) in Cuba in 1973 to that in 1981?
Offer a very short reply. 0.93. What is the ratio of the Pupil-teacher ratio(headcount basis) in Kiribati in 1973 to that in 1981?
Offer a very short reply. 0.82. What is the ratio of the Pupil-teacher ratio(headcount basis) in Malta in 1973 to that in 1981?
Keep it short and to the point. 1.09. What is the ratio of the Pupil-teacher ratio(headcount basis) of Panama in 1973 to that in 1981?
Keep it short and to the point. 1.02. What is the ratio of the Pupil-teacher ratio(headcount basis) in Cuba in 1973 to that in 1982?
Your response must be concise. 0.96. What is the ratio of the Pupil-teacher ratio(headcount basis) of Kiribati in 1973 to that in 1982?
Provide a short and direct response. 0.82. What is the ratio of the Pupil-teacher ratio(headcount basis) of Malta in 1973 to that in 1982?
Keep it short and to the point. 1.06. What is the ratio of the Pupil-teacher ratio(headcount basis) in Panama in 1973 to that in 1982?
Provide a short and direct response. 1.05. What is the ratio of the Pupil-teacher ratio(headcount basis) in Cuba in 1973 to that in 1983?
Give a very brief answer. 1.02. What is the ratio of the Pupil-teacher ratio(headcount basis) in Kiribati in 1973 to that in 1983?
Your answer should be compact. 0.81. What is the ratio of the Pupil-teacher ratio(headcount basis) of Malta in 1973 to that in 1983?
Provide a succinct answer. 1.07. What is the ratio of the Pupil-teacher ratio(headcount basis) of Panama in 1973 to that in 1983?
Keep it short and to the point. 1.07. What is the ratio of the Pupil-teacher ratio(headcount basis) in Cuba in 1974 to that in 1977?
Give a very brief answer. 0.85. What is the ratio of the Pupil-teacher ratio(headcount basis) in Kiribati in 1974 to that in 1977?
Offer a very short reply. 0.9. What is the ratio of the Pupil-teacher ratio(headcount basis) of Malta in 1974 to that in 1977?
Offer a terse response. 1.01. What is the ratio of the Pupil-teacher ratio(headcount basis) in Panama in 1974 to that in 1977?
Give a very brief answer. 0.81. What is the ratio of the Pupil-teacher ratio(headcount basis) in Cuba in 1974 to that in 1980?
Ensure brevity in your answer.  0.89. What is the ratio of the Pupil-teacher ratio(headcount basis) in Kiribati in 1974 to that in 1980?
Your answer should be compact. 0.72. What is the ratio of the Pupil-teacher ratio(headcount basis) in Panama in 1974 to that in 1980?
Your answer should be very brief. 1.01. What is the ratio of the Pupil-teacher ratio(headcount basis) of Cuba in 1974 to that in 1981?
Your answer should be very brief. 0.91. What is the ratio of the Pupil-teacher ratio(headcount basis) in Kiribati in 1974 to that in 1981?
Your answer should be very brief. 0.79. What is the ratio of the Pupil-teacher ratio(headcount basis) of Malta in 1974 to that in 1981?
Keep it short and to the point. 1.04. What is the ratio of the Pupil-teacher ratio(headcount basis) in Panama in 1974 to that in 1981?
Offer a terse response. 1.05. What is the ratio of the Pupil-teacher ratio(headcount basis) of Cuba in 1974 to that in 1982?
Provide a short and direct response. 0.95. What is the ratio of the Pupil-teacher ratio(headcount basis) of Kiribati in 1974 to that in 1982?
Your response must be concise. 0.79. What is the ratio of the Pupil-teacher ratio(headcount basis) in Panama in 1974 to that in 1982?
Keep it short and to the point. 1.09. What is the ratio of the Pupil-teacher ratio(headcount basis) in Kiribati in 1974 to that in 1983?
Offer a terse response. 0.78. What is the ratio of the Pupil-teacher ratio(headcount basis) of Malta in 1974 to that in 1983?
Offer a very short reply. 1.03. What is the ratio of the Pupil-teacher ratio(headcount basis) of Panama in 1974 to that in 1983?
Offer a very short reply. 1.11. What is the ratio of the Pupil-teacher ratio(headcount basis) of Cuba in 1977 to that in 1980?
Provide a short and direct response. 1.05. What is the ratio of the Pupil-teacher ratio(headcount basis) in Kiribati in 1977 to that in 1980?
Offer a terse response. 0.8. What is the ratio of the Pupil-teacher ratio(headcount basis) of Malta in 1977 to that in 1980?
Make the answer very short. 0.99. What is the ratio of the Pupil-teacher ratio(headcount basis) in Panama in 1977 to that in 1980?
Offer a terse response. 1.25. What is the ratio of the Pupil-teacher ratio(headcount basis) in Cuba in 1977 to that in 1981?
Your response must be concise. 1.08. What is the ratio of the Pupil-teacher ratio(headcount basis) in Kiribati in 1977 to that in 1981?
Your response must be concise. 0.88. What is the ratio of the Pupil-teacher ratio(headcount basis) in Malta in 1977 to that in 1981?
Provide a succinct answer. 1.03. What is the ratio of the Pupil-teacher ratio(headcount basis) of Panama in 1977 to that in 1981?
Provide a succinct answer. 1.3. What is the ratio of the Pupil-teacher ratio(headcount basis) of Cuba in 1977 to that in 1982?
Your response must be concise. 1.11. What is the ratio of the Pupil-teacher ratio(headcount basis) of Kiribati in 1977 to that in 1982?
Keep it short and to the point. 0.88. What is the ratio of the Pupil-teacher ratio(headcount basis) of Panama in 1977 to that in 1982?
Your answer should be compact. 1.34. What is the ratio of the Pupil-teacher ratio(headcount basis) in Cuba in 1977 to that in 1983?
Your answer should be compact. 1.18. What is the ratio of the Pupil-teacher ratio(headcount basis) of Kiribati in 1977 to that in 1983?
Your response must be concise. 0.87. What is the ratio of the Pupil-teacher ratio(headcount basis) of Malta in 1977 to that in 1983?
Give a very brief answer. 1.01. What is the ratio of the Pupil-teacher ratio(headcount basis) of Panama in 1977 to that in 1983?
Give a very brief answer. 1.37. What is the ratio of the Pupil-teacher ratio(headcount basis) of Cuba in 1980 to that in 1981?
Provide a succinct answer. 1.03. What is the ratio of the Pupil-teacher ratio(headcount basis) of Kiribati in 1980 to that in 1981?
Keep it short and to the point. 1.09. What is the ratio of the Pupil-teacher ratio(headcount basis) in Malta in 1980 to that in 1981?
Ensure brevity in your answer.  1.04. What is the ratio of the Pupil-teacher ratio(headcount basis) in Panama in 1980 to that in 1981?
Your answer should be compact. 1.04. What is the ratio of the Pupil-teacher ratio(headcount basis) in Cuba in 1980 to that in 1982?
Make the answer very short. 1.06. What is the ratio of the Pupil-teacher ratio(headcount basis) of Kiribati in 1980 to that in 1982?
Offer a very short reply. 1.09. What is the ratio of the Pupil-teacher ratio(headcount basis) of Malta in 1980 to that in 1982?
Your answer should be compact. 1.01. What is the ratio of the Pupil-teacher ratio(headcount basis) in Panama in 1980 to that in 1982?
Your response must be concise. 1.07. What is the ratio of the Pupil-teacher ratio(headcount basis) of Cuba in 1980 to that in 1983?
Your answer should be very brief. 1.13. What is the ratio of the Pupil-teacher ratio(headcount basis) of Kiribati in 1980 to that in 1983?
Make the answer very short. 1.08. What is the ratio of the Pupil-teacher ratio(headcount basis) of Malta in 1980 to that in 1983?
Provide a short and direct response. 1.03. What is the ratio of the Pupil-teacher ratio(headcount basis) in Panama in 1980 to that in 1983?
Offer a very short reply. 1.1. What is the ratio of the Pupil-teacher ratio(headcount basis) of Cuba in 1981 to that in 1982?
Make the answer very short. 1.03. What is the ratio of the Pupil-teacher ratio(headcount basis) in Malta in 1981 to that in 1982?
Offer a terse response. 0.97. What is the ratio of the Pupil-teacher ratio(headcount basis) of Panama in 1981 to that in 1982?
Your answer should be compact. 1.03. What is the ratio of the Pupil-teacher ratio(headcount basis) of Cuba in 1981 to that in 1983?
Offer a terse response. 1.1. What is the ratio of the Pupil-teacher ratio(headcount basis) of Malta in 1981 to that in 1983?
Provide a succinct answer. 0.98. What is the ratio of the Pupil-teacher ratio(headcount basis) of Panama in 1981 to that in 1983?
Provide a short and direct response. 1.05. What is the ratio of the Pupil-teacher ratio(headcount basis) in Cuba in 1982 to that in 1983?
Give a very brief answer. 1.06. What is the ratio of the Pupil-teacher ratio(headcount basis) in Kiribati in 1982 to that in 1983?
Keep it short and to the point. 0.99. What is the ratio of the Pupil-teacher ratio(headcount basis) in Malta in 1982 to that in 1983?
Your answer should be compact. 1.01. What is the ratio of the Pupil-teacher ratio(headcount basis) in Panama in 1982 to that in 1983?
Your answer should be very brief. 1.02. What is the difference between the highest and the second highest Pupil-teacher ratio(headcount basis) in Cuba?
Keep it short and to the point. 0.66. What is the difference between the highest and the second highest Pupil-teacher ratio(headcount basis) of Kiribati?
Provide a short and direct response. 1.22. What is the difference between the highest and the second highest Pupil-teacher ratio(headcount basis) of Malta?
Your answer should be very brief. 0.54. What is the difference between the highest and the second highest Pupil-teacher ratio(headcount basis) of Panama?
Your response must be concise. 4.96. What is the difference between the highest and the lowest Pupil-teacher ratio(headcount basis) in Cuba?
Offer a terse response. 2.17. What is the difference between the highest and the lowest Pupil-teacher ratio(headcount basis) in Kiribati?
Ensure brevity in your answer.  4.38. What is the difference between the highest and the lowest Pupil-teacher ratio(headcount basis) in Malta?
Give a very brief answer. 1.07. What is the difference between the highest and the lowest Pupil-teacher ratio(headcount basis) in Panama?
Your answer should be very brief. 7.04. 